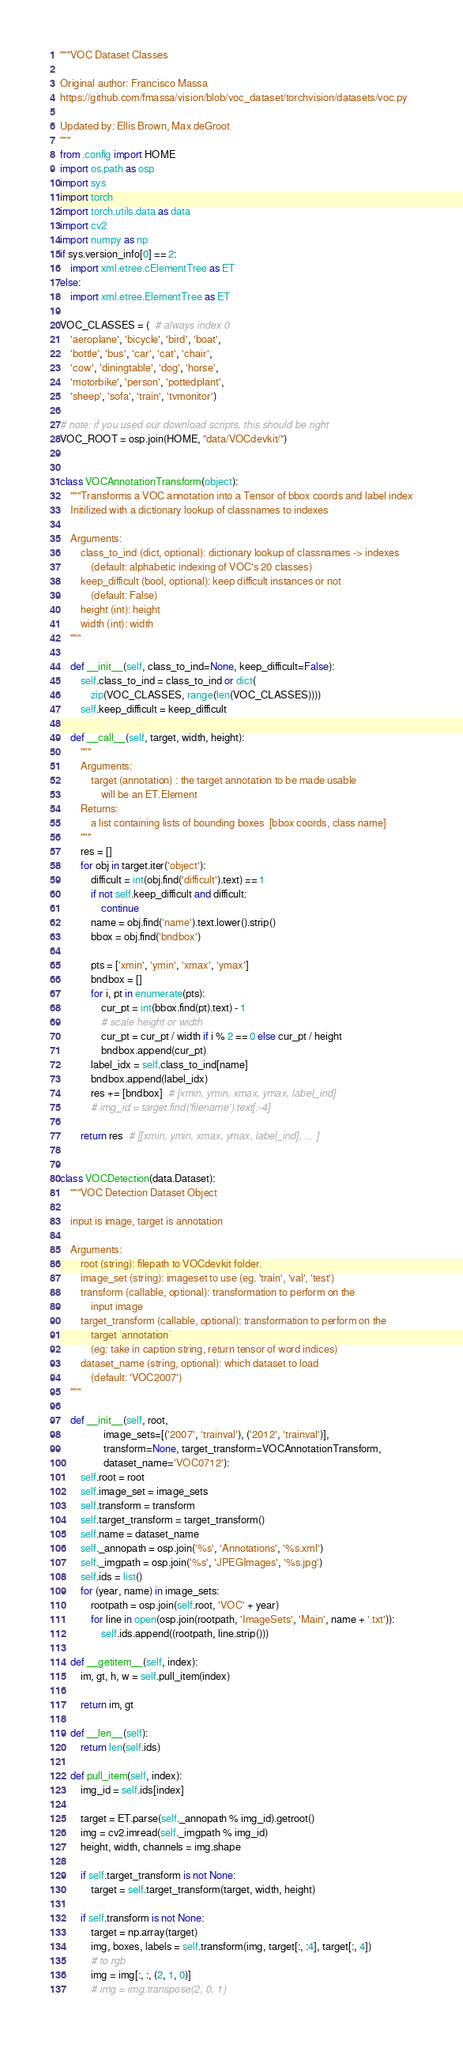Convert code to text. <code><loc_0><loc_0><loc_500><loc_500><_Python_>"""VOC Dataset Classes

Original author: Francisco Massa
https://github.com/fmassa/vision/blob/voc_dataset/torchvision/datasets/voc.py

Updated by: Ellis Brown, Max deGroot
"""
from .config import HOME
import os.path as osp
import sys
import torch
import torch.utils.data as data
import cv2
import numpy as np
if sys.version_info[0] == 2:
    import xml.etree.cElementTree as ET
else:
    import xml.etree.ElementTree as ET

VOC_CLASSES = (  # always index 0
    'aeroplane', 'bicycle', 'bird', 'boat',
    'bottle', 'bus', 'car', 'cat', 'chair',
    'cow', 'diningtable', 'dog', 'horse',
    'motorbike', 'person', 'pottedplant',
    'sheep', 'sofa', 'train', 'tvmonitor')

# note: if you used our download scripts, this should be right
VOC_ROOT = osp.join(HOME, "data/VOCdevkit/")


class VOCAnnotationTransform(object):
    """Transforms a VOC annotation into a Tensor of bbox coords and label index
    Initilized with a dictionary lookup of classnames to indexes

    Arguments:
        class_to_ind (dict, optional): dictionary lookup of classnames -> indexes
            (default: alphabetic indexing of VOC's 20 classes)
        keep_difficult (bool, optional): keep difficult instances or not
            (default: False)
        height (int): height
        width (int): width
    """

    def __init__(self, class_to_ind=None, keep_difficult=False):
        self.class_to_ind = class_to_ind or dict(
            zip(VOC_CLASSES, range(len(VOC_CLASSES))))
        self.keep_difficult = keep_difficult

    def __call__(self, target, width, height):
        """
        Arguments:
            target (annotation) : the target annotation to be made usable
                will be an ET.Element
        Returns:
            a list containing lists of bounding boxes  [bbox coords, class name]
        """
        res = []
        for obj in target.iter('object'):
            difficult = int(obj.find('difficult').text) == 1
            if not self.keep_difficult and difficult:
                continue
            name = obj.find('name').text.lower().strip()
            bbox = obj.find('bndbox')

            pts = ['xmin', 'ymin', 'xmax', 'ymax']
            bndbox = []
            for i, pt in enumerate(pts):
                cur_pt = int(bbox.find(pt).text) - 1
                # scale height or width
                cur_pt = cur_pt / width if i % 2 == 0 else cur_pt / height
                bndbox.append(cur_pt)
            label_idx = self.class_to_ind[name]
            bndbox.append(label_idx)
            res += [bndbox]  # [xmin, ymin, xmax, ymax, label_ind]
            # img_id = target.find('filename').text[:-4]

        return res  # [[xmin, ymin, xmax, ymax, label_ind], ... ]


class VOCDetection(data.Dataset):
    """VOC Detection Dataset Object

    input is image, target is annotation

    Arguments:
        root (string): filepath to VOCdevkit folder.
        image_set (string): imageset to use (eg. 'train', 'val', 'test')
        transform (callable, optional): transformation to perform on the
            input image
        target_transform (callable, optional): transformation to perform on the
            target `annotation`
            (eg: take in caption string, return tensor of word indices)
        dataset_name (string, optional): which dataset to load
            (default: 'VOC2007')
    """

    def __init__(self, root,
                 image_sets=[('2007', 'trainval'), ('2012', 'trainval')],
                 transform=None, target_transform=VOCAnnotationTransform,
                 dataset_name='VOC0712'):
        self.root = root
        self.image_set = image_sets
        self.transform = transform
        self.target_transform = target_transform()
        self.name = dataset_name
        self._annopath = osp.join('%s', 'Annotations', '%s.xml')
        self._imgpath = osp.join('%s', 'JPEGImages', '%s.jpg')
        self.ids = list()
        for (year, name) in image_sets:
            rootpath = osp.join(self.root, 'VOC' + year)
            for line in open(osp.join(rootpath, 'ImageSets', 'Main', name + '.txt')):
                self.ids.append((rootpath, line.strip()))

    def __getitem__(self, index):
        im, gt, h, w = self.pull_item(index)

        return im, gt

    def __len__(self):
        return len(self.ids)

    def pull_item(self, index):
        img_id = self.ids[index]

        target = ET.parse(self._annopath % img_id).getroot()
        img = cv2.imread(self._imgpath % img_id)
        height, width, channels = img.shape

        if self.target_transform is not None:
            target = self.target_transform(target, width, height)

        if self.transform is not None:
            target = np.array(target)
            img, boxes, labels = self.transform(img, target[:, :4], target[:, 4])
            # to rgb
            img = img[:, :, (2, 1, 0)]
            # img = img.transpose(2, 0, 1)</code> 